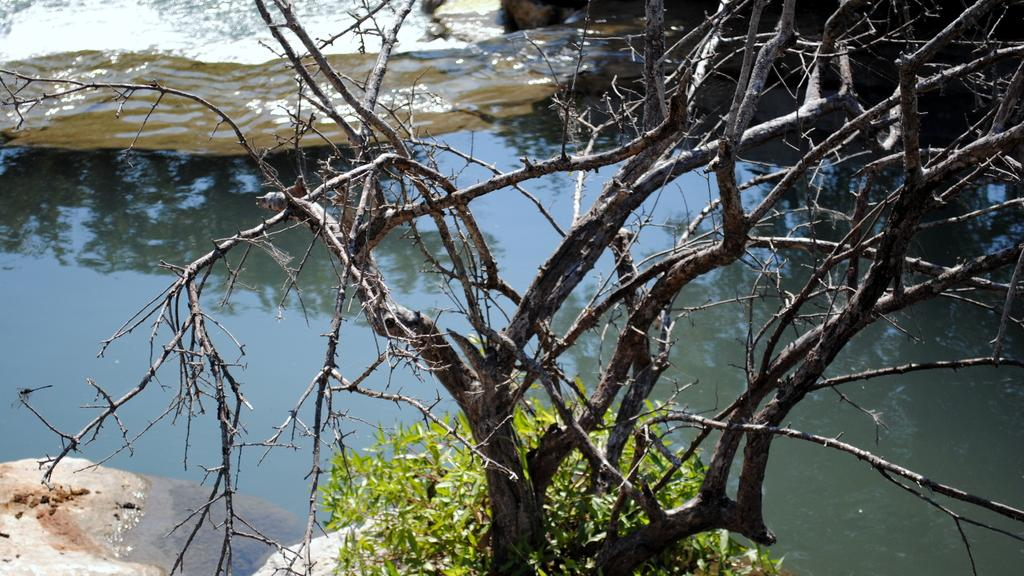Where was the image taken? The image was taken outdoors. What can be seen at the bottom of the image? There is a rock and a tree at the bottom of the image. What is in the middle of the image? There is a pond with water in the middle of the image. What can be seen at the top of the image? There is a rock at the top of the image. What type of plate is being used to hold the water in the pond? There is no plate present in the image; the water is in a natural pond. 